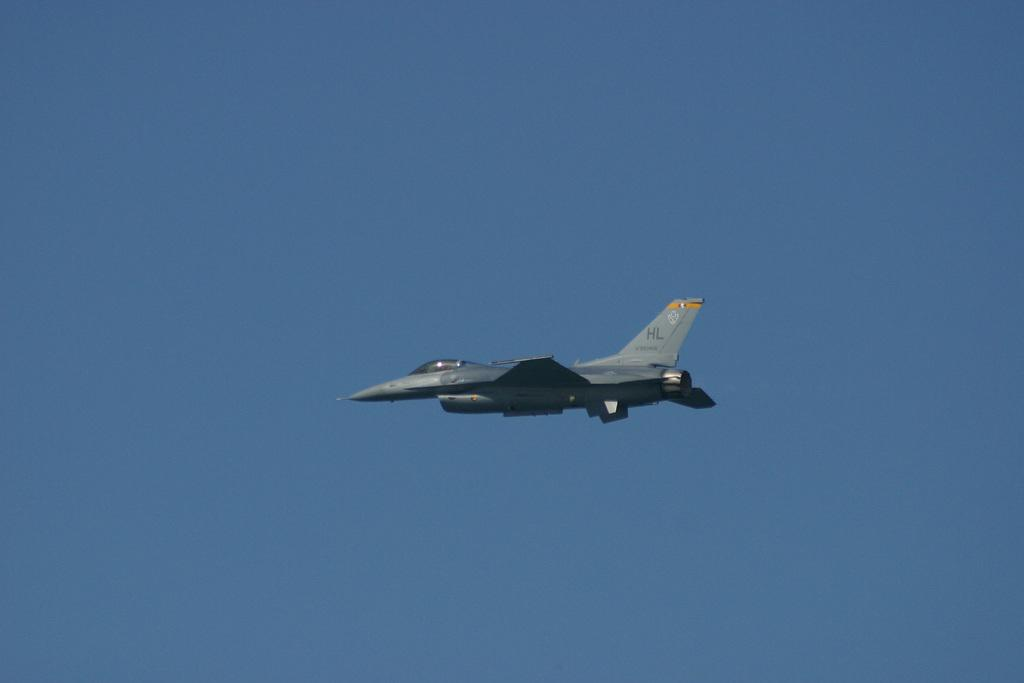What is the main subject of the image? The main subject of the image is an airplane. What is the airplane doing in the image? The airplane is flying in the sky. What type of square can be seen on the actor's face in the image? There is no actor or square present in the image; it features an airplane flying in the sky. 